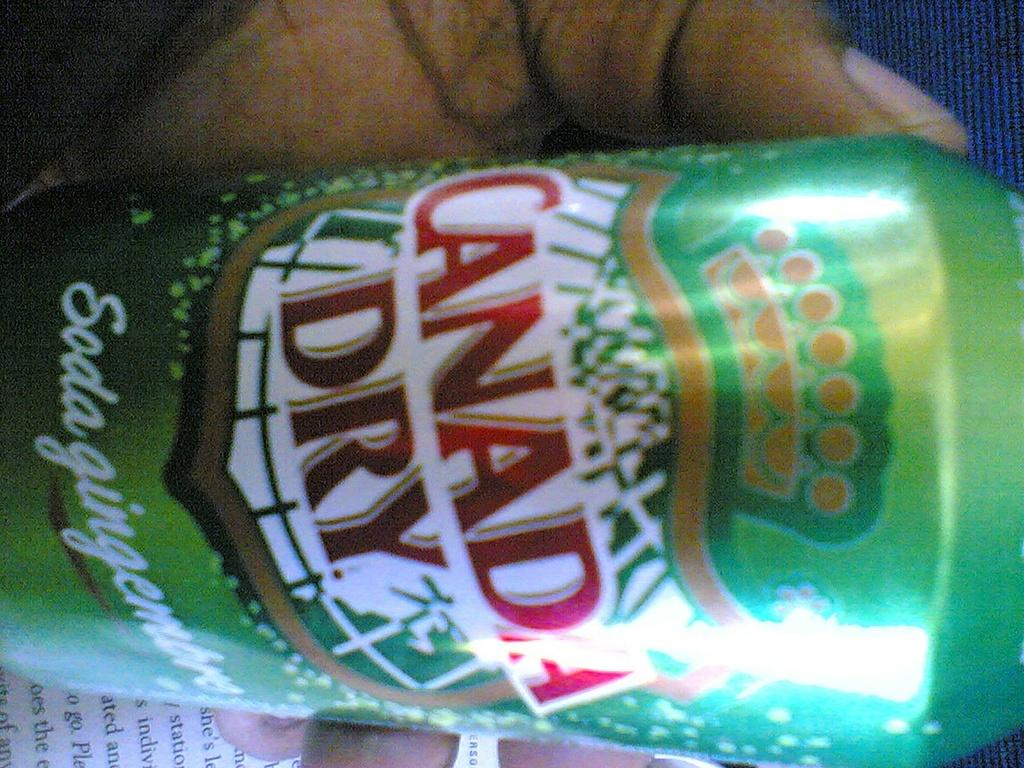Who is present in the image? There is a person in the image. What is the person holding in the image? The person is holding a coke tin. What can be seen at the bottom of the image? There is a paper at the bottom of the image. What type of clothing is visible at the top of the image? There are blue jeans at the top of the image. How much debt is the person in the image facing? There is no information about the person's debt in the image. 